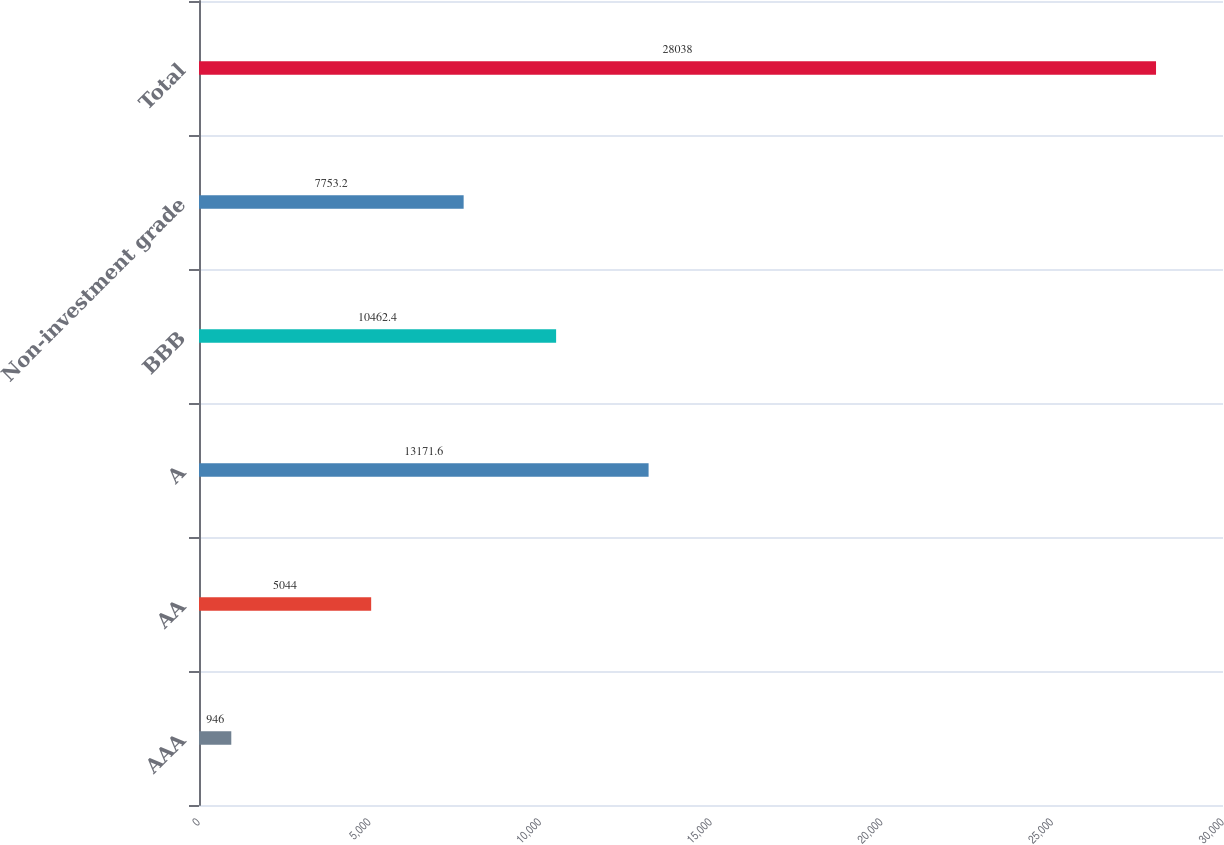Convert chart. <chart><loc_0><loc_0><loc_500><loc_500><bar_chart><fcel>AAA<fcel>AA<fcel>A<fcel>BBB<fcel>Non-investment grade<fcel>Total<nl><fcel>946<fcel>5044<fcel>13171.6<fcel>10462.4<fcel>7753.2<fcel>28038<nl></chart> 